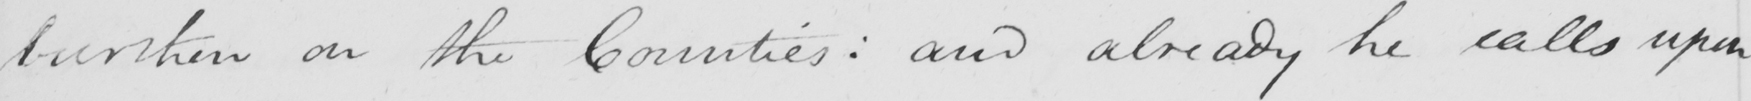What does this handwritten line say? burthen on the Counties :  and already he calls upon 